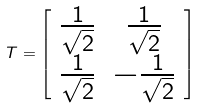<formula> <loc_0><loc_0><loc_500><loc_500>T = \left [ \begin{array} { c c } \frac { 1 } { \sqrt { 2 } } & \frac { 1 } { \sqrt { 2 } } \\ \frac { 1 } { \sqrt { 2 } } & - \frac { 1 } { \sqrt { 2 } } \end{array} \right ]</formula> 